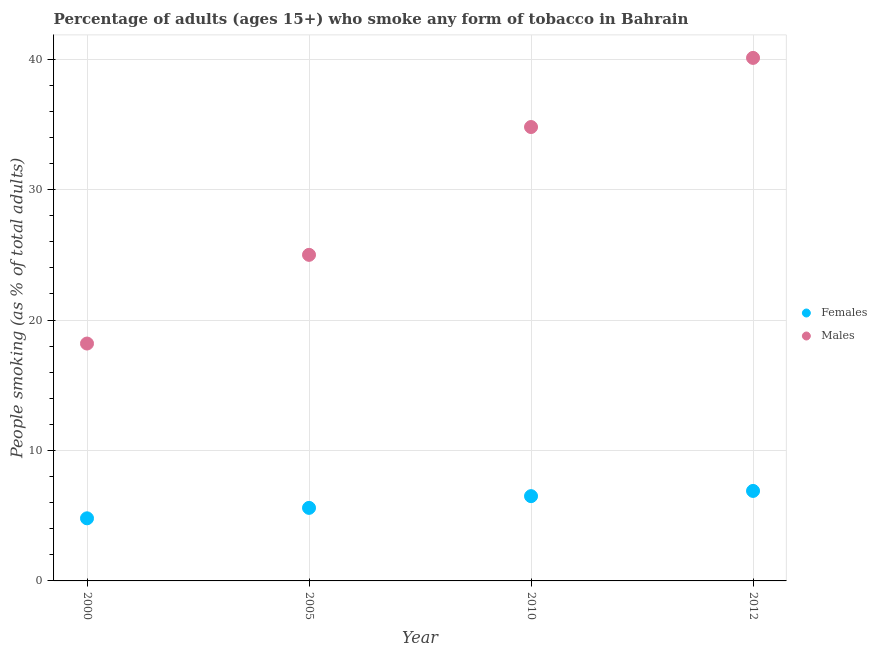How many different coloured dotlines are there?
Provide a succinct answer. 2. Across all years, what is the maximum percentage of males who smoke?
Keep it short and to the point. 40.1. Across all years, what is the minimum percentage of females who smoke?
Offer a very short reply. 4.8. In which year was the percentage of males who smoke minimum?
Give a very brief answer. 2000. What is the total percentage of females who smoke in the graph?
Make the answer very short. 23.8. What is the difference between the percentage of females who smoke in 2005 and that in 2010?
Keep it short and to the point. -0.9. What is the difference between the percentage of females who smoke in 2012 and the percentage of males who smoke in 2000?
Keep it short and to the point. -11.3. What is the average percentage of females who smoke per year?
Your answer should be very brief. 5.95. In the year 2010, what is the difference between the percentage of females who smoke and percentage of males who smoke?
Offer a very short reply. -28.3. What is the ratio of the percentage of males who smoke in 2000 to that in 2010?
Give a very brief answer. 0.52. Is the difference between the percentage of males who smoke in 2005 and 2010 greater than the difference between the percentage of females who smoke in 2005 and 2010?
Your answer should be very brief. No. What is the difference between the highest and the second highest percentage of males who smoke?
Provide a succinct answer. 5.3. What is the difference between the highest and the lowest percentage of females who smoke?
Make the answer very short. 2.1. Is the sum of the percentage of females who smoke in 2005 and 2010 greater than the maximum percentage of males who smoke across all years?
Your answer should be compact. No. Does the percentage of males who smoke monotonically increase over the years?
Your answer should be compact. Yes. Is the percentage of males who smoke strictly less than the percentage of females who smoke over the years?
Provide a short and direct response. No. How many dotlines are there?
Offer a very short reply. 2. How many years are there in the graph?
Your answer should be compact. 4. What is the difference between two consecutive major ticks on the Y-axis?
Make the answer very short. 10. Does the graph contain any zero values?
Offer a terse response. No. How many legend labels are there?
Provide a succinct answer. 2. How are the legend labels stacked?
Give a very brief answer. Vertical. What is the title of the graph?
Keep it short and to the point. Percentage of adults (ages 15+) who smoke any form of tobacco in Bahrain. Does "Forest" appear as one of the legend labels in the graph?
Ensure brevity in your answer.  No. What is the label or title of the X-axis?
Keep it short and to the point. Year. What is the label or title of the Y-axis?
Offer a very short reply. People smoking (as % of total adults). What is the People smoking (as % of total adults) in Males in 2010?
Offer a terse response. 34.8. What is the People smoking (as % of total adults) in Males in 2012?
Your answer should be very brief. 40.1. Across all years, what is the maximum People smoking (as % of total adults) of Males?
Provide a short and direct response. 40.1. Across all years, what is the minimum People smoking (as % of total adults) in Females?
Offer a terse response. 4.8. What is the total People smoking (as % of total adults) of Females in the graph?
Offer a very short reply. 23.8. What is the total People smoking (as % of total adults) in Males in the graph?
Your answer should be compact. 118.1. What is the difference between the People smoking (as % of total adults) in Females in 2000 and that in 2005?
Provide a succinct answer. -0.8. What is the difference between the People smoking (as % of total adults) in Males in 2000 and that in 2010?
Offer a terse response. -16.6. What is the difference between the People smoking (as % of total adults) of Females in 2000 and that in 2012?
Ensure brevity in your answer.  -2.1. What is the difference between the People smoking (as % of total adults) of Males in 2000 and that in 2012?
Ensure brevity in your answer.  -21.9. What is the difference between the People smoking (as % of total adults) in Males in 2005 and that in 2010?
Offer a terse response. -9.8. What is the difference between the People smoking (as % of total adults) of Males in 2005 and that in 2012?
Your response must be concise. -15.1. What is the difference between the People smoking (as % of total adults) in Females in 2010 and that in 2012?
Offer a very short reply. -0.4. What is the difference between the People smoking (as % of total adults) in Males in 2010 and that in 2012?
Offer a terse response. -5.3. What is the difference between the People smoking (as % of total adults) of Females in 2000 and the People smoking (as % of total adults) of Males in 2005?
Offer a terse response. -20.2. What is the difference between the People smoking (as % of total adults) in Females in 2000 and the People smoking (as % of total adults) in Males in 2012?
Offer a terse response. -35.3. What is the difference between the People smoking (as % of total adults) of Females in 2005 and the People smoking (as % of total adults) of Males in 2010?
Keep it short and to the point. -29.2. What is the difference between the People smoking (as % of total adults) of Females in 2005 and the People smoking (as % of total adults) of Males in 2012?
Your answer should be very brief. -34.5. What is the difference between the People smoking (as % of total adults) of Females in 2010 and the People smoking (as % of total adults) of Males in 2012?
Provide a short and direct response. -33.6. What is the average People smoking (as % of total adults) in Females per year?
Keep it short and to the point. 5.95. What is the average People smoking (as % of total adults) of Males per year?
Provide a short and direct response. 29.52. In the year 2005, what is the difference between the People smoking (as % of total adults) of Females and People smoking (as % of total adults) of Males?
Ensure brevity in your answer.  -19.4. In the year 2010, what is the difference between the People smoking (as % of total adults) of Females and People smoking (as % of total adults) of Males?
Offer a terse response. -28.3. In the year 2012, what is the difference between the People smoking (as % of total adults) of Females and People smoking (as % of total adults) of Males?
Your answer should be very brief. -33.2. What is the ratio of the People smoking (as % of total adults) of Females in 2000 to that in 2005?
Provide a succinct answer. 0.86. What is the ratio of the People smoking (as % of total adults) of Males in 2000 to that in 2005?
Offer a terse response. 0.73. What is the ratio of the People smoking (as % of total adults) of Females in 2000 to that in 2010?
Give a very brief answer. 0.74. What is the ratio of the People smoking (as % of total adults) in Males in 2000 to that in 2010?
Give a very brief answer. 0.52. What is the ratio of the People smoking (as % of total adults) of Females in 2000 to that in 2012?
Make the answer very short. 0.7. What is the ratio of the People smoking (as % of total adults) of Males in 2000 to that in 2012?
Ensure brevity in your answer.  0.45. What is the ratio of the People smoking (as % of total adults) of Females in 2005 to that in 2010?
Offer a very short reply. 0.86. What is the ratio of the People smoking (as % of total adults) of Males in 2005 to that in 2010?
Provide a short and direct response. 0.72. What is the ratio of the People smoking (as % of total adults) in Females in 2005 to that in 2012?
Your answer should be very brief. 0.81. What is the ratio of the People smoking (as % of total adults) in Males in 2005 to that in 2012?
Provide a succinct answer. 0.62. What is the ratio of the People smoking (as % of total adults) in Females in 2010 to that in 2012?
Provide a succinct answer. 0.94. What is the ratio of the People smoking (as % of total adults) in Males in 2010 to that in 2012?
Keep it short and to the point. 0.87. What is the difference between the highest and the lowest People smoking (as % of total adults) of Males?
Keep it short and to the point. 21.9. 